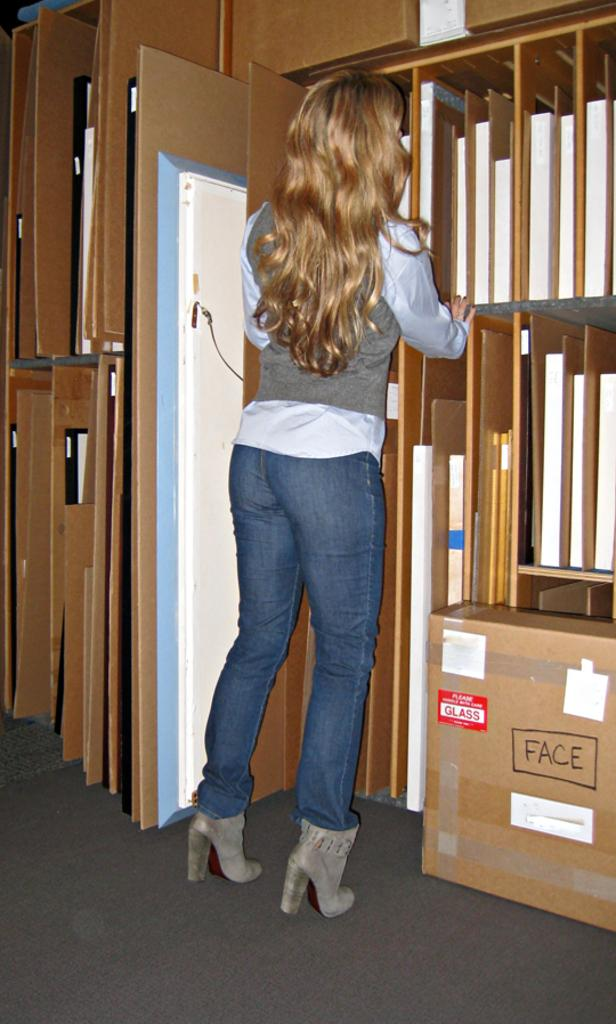<image>
Create a compact narrative representing the image presented. A woman looks for an item while standing next to a cardboard box labeled FACE. 